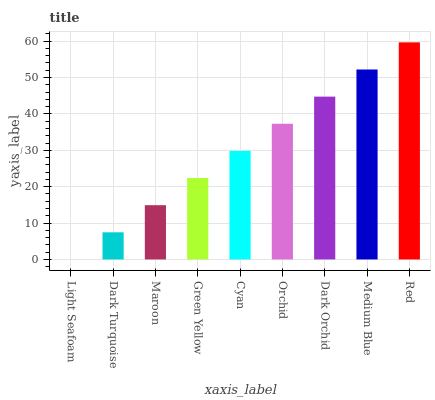Is Light Seafoam the minimum?
Answer yes or no. Yes. Is Red the maximum?
Answer yes or no. Yes. Is Dark Turquoise the minimum?
Answer yes or no. No. Is Dark Turquoise the maximum?
Answer yes or no. No. Is Dark Turquoise greater than Light Seafoam?
Answer yes or no. Yes. Is Light Seafoam less than Dark Turquoise?
Answer yes or no. Yes. Is Light Seafoam greater than Dark Turquoise?
Answer yes or no. No. Is Dark Turquoise less than Light Seafoam?
Answer yes or no. No. Is Cyan the high median?
Answer yes or no. Yes. Is Cyan the low median?
Answer yes or no. Yes. Is Medium Blue the high median?
Answer yes or no. No. Is Orchid the low median?
Answer yes or no. No. 